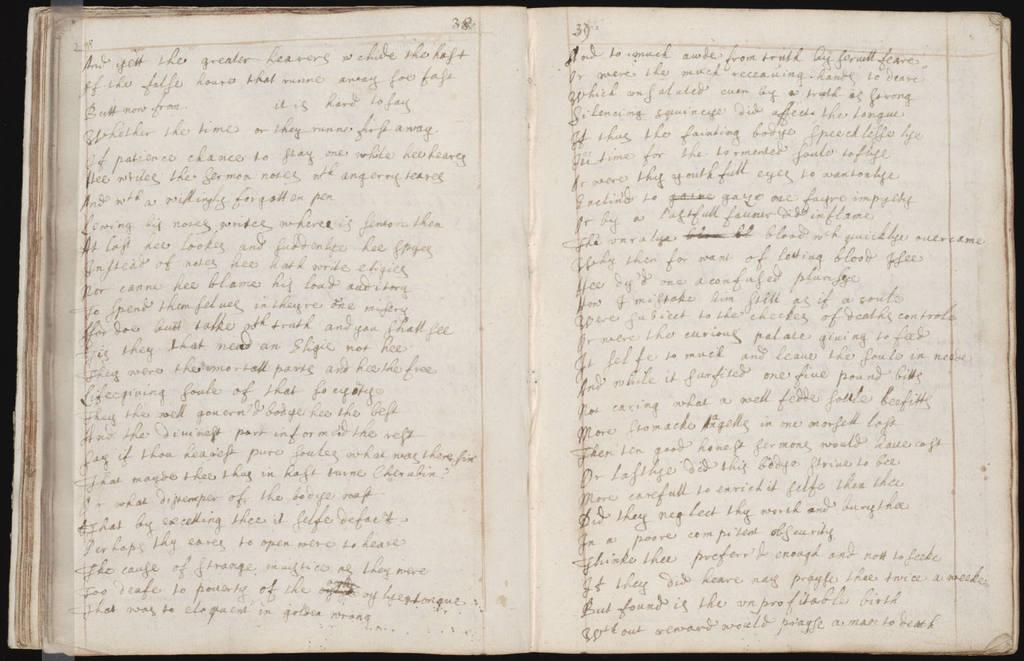<image>
Summarize the visual content of the image. A book containing cursive writing. The word At is visible on the left. 